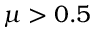Convert formula to latex. <formula><loc_0><loc_0><loc_500><loc_500>\mu > 0 . 5</formula> 